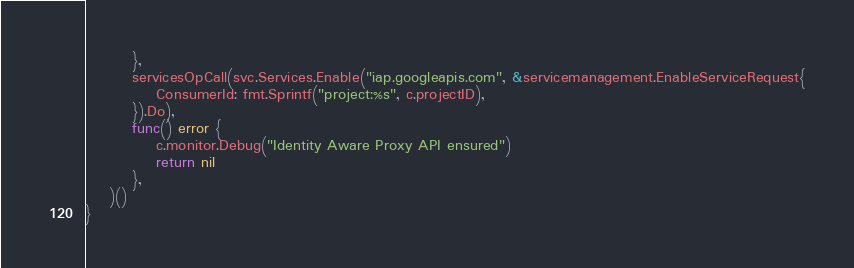<code> <loc_0><loc_0><loc_500><loc_500><_Go_>		},
		servicesOpCall(svc.Services.Enable("iap.googleapis.com", &servicemanagement.EnableServiceRequest{
			ConsumerId: fmt.Sprintf("project:%s", c.projectID),
		}).Do),
		func() error {
			c.monitor.Debug("Identity Aware Proxy API ensured")
			return nil
		},
	)()
}
</code> 